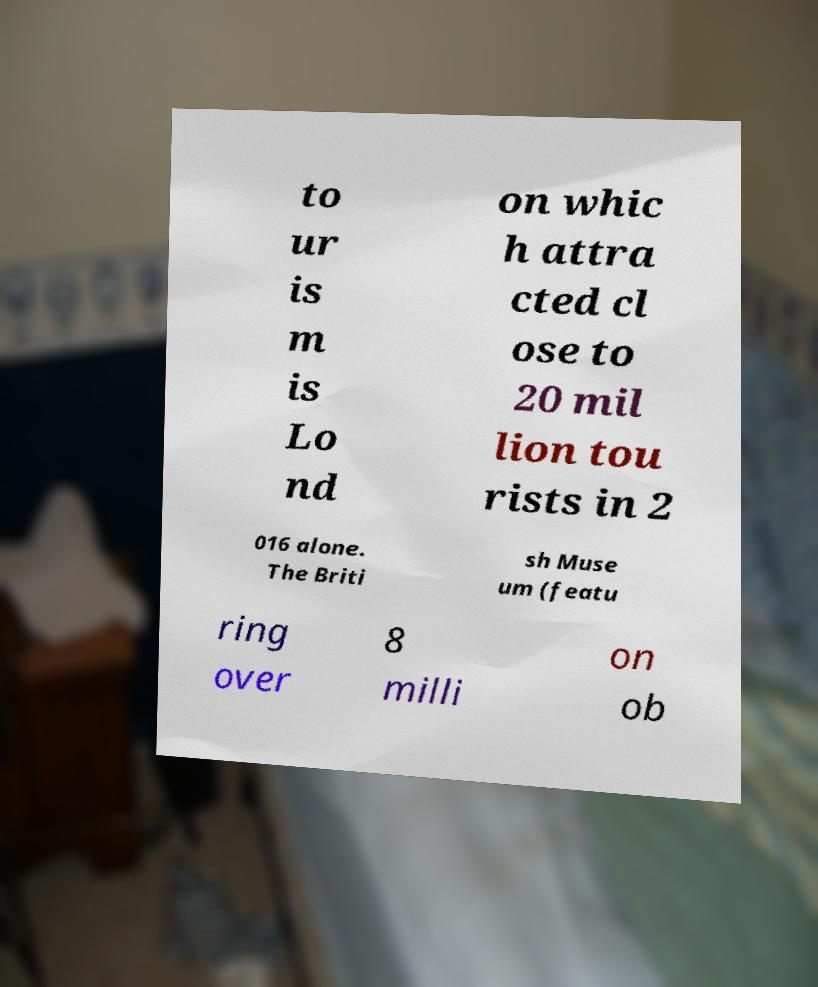I need the written content from this picture converted into text. Can you do that? to ur is m is Lo nd on whic h attra cted cl ose to 20 mil lion tou rists in 2 016 alone. The Briti sh Muse um (featu ring over 8 milli on ob 